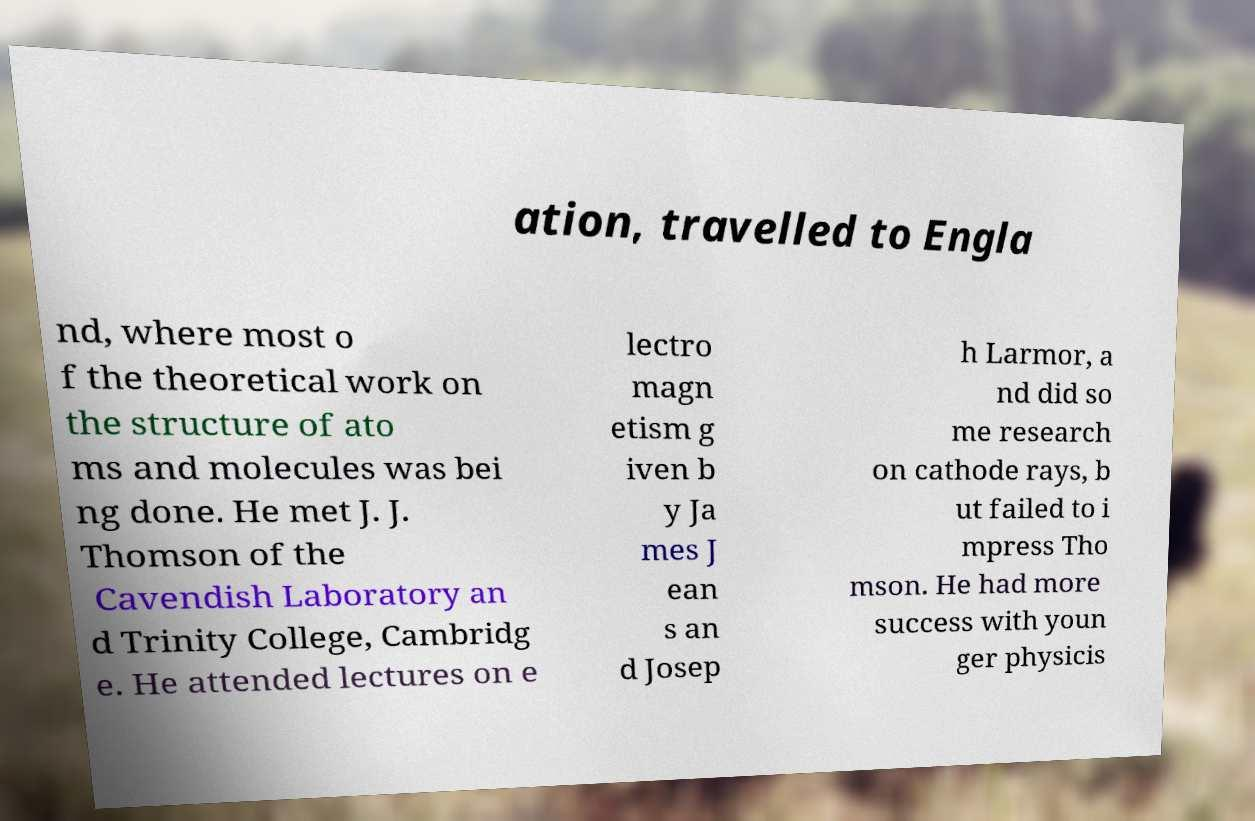Could you assist in decoding the text presented in this image and type it out clearly? ation, travelled to Engla nd, where most o f the theoretical work on the structure of ato ms and molecules was bei ng done. He met J. J. Thomson of the Cavendish Laboratory an d Trinity College, Cambridg e. He attended lectures on e lectro magn etism g iven b y Ja mes J ean s an d Josep h Larmor, a nd did so me research on cathode rays, b ut failed to i mpress Tho mson. He had more success with youn ger physicis 